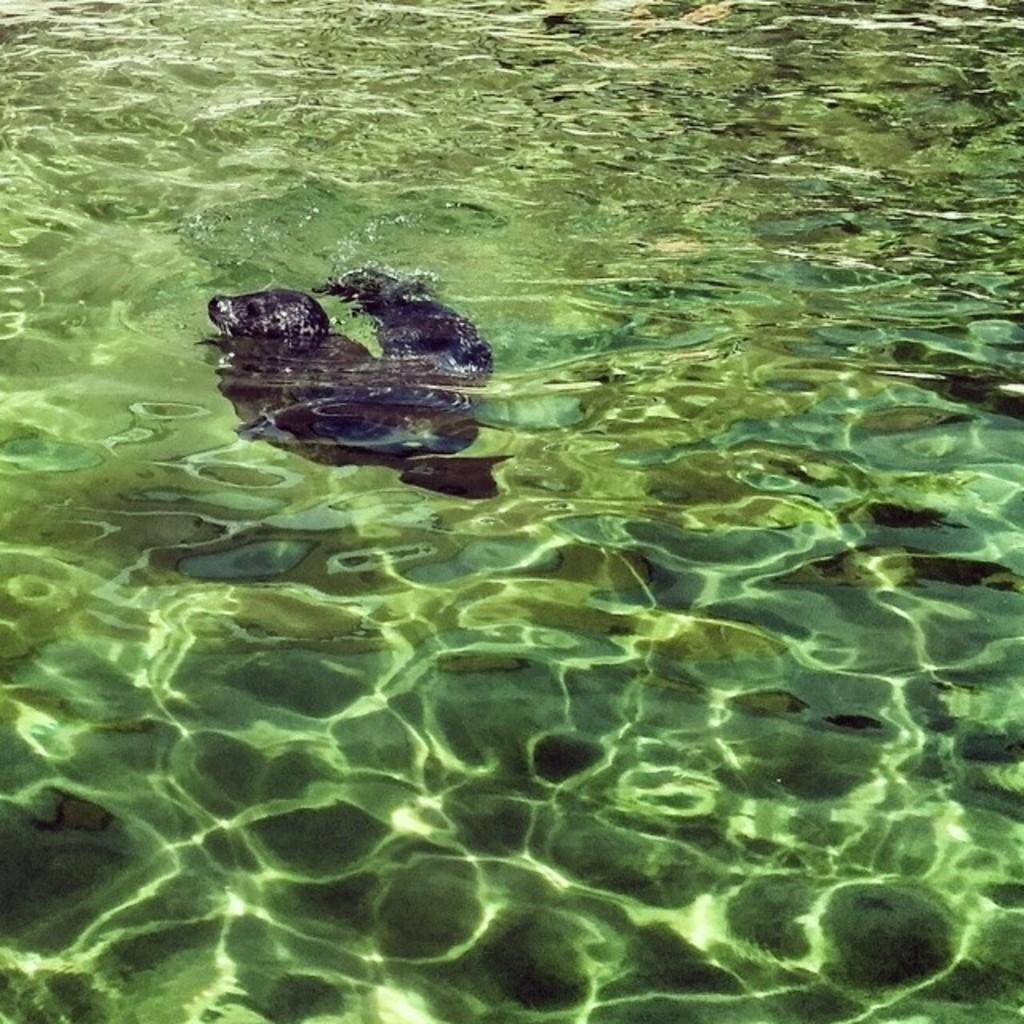What is the primary element visible in the image? There is water in the image. Can you describe any objects or features present within the water? There is an unspecified object or feature present in the water. How does the mist in the image compare to the fog in another image? There is no mist present in the image, as it only features water and an unspecified object or feature within the water. 